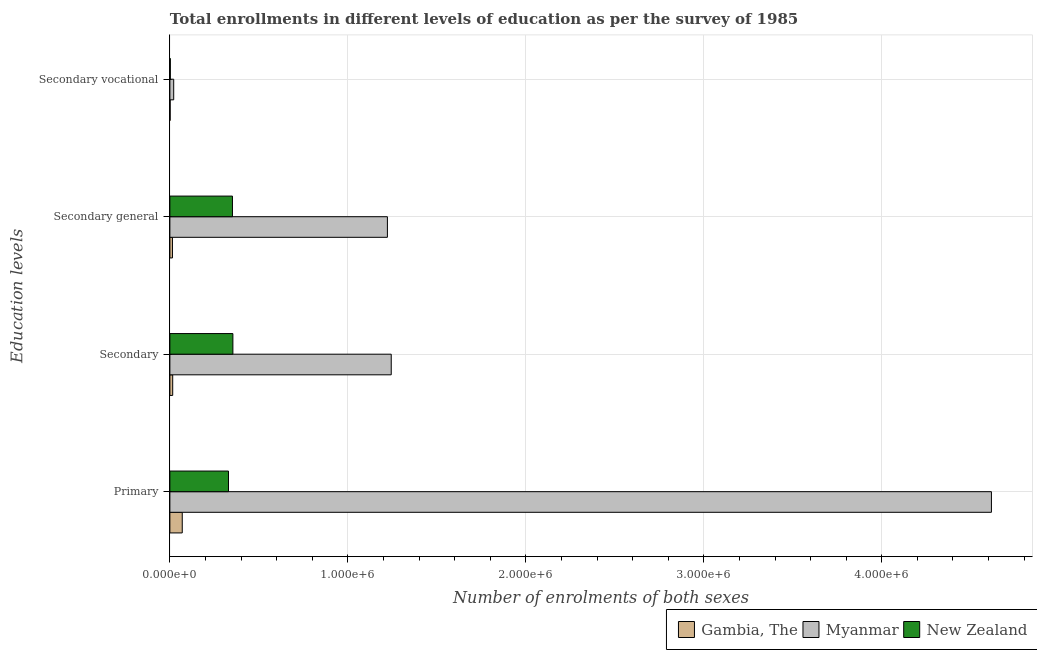How many different coloured bars are there?
Make the answer very short. 3. How many groups of bars are there?
Your answer should be compact. 4. Are the number of bars per tick equal to the number of legend labels?
Provide a succinct answer. Yes. Are the number of bars on each tick of the Y-axis equal?
Provide a succinct answer. Yes. What is the label of the 2nd group of bars from the top?
Your response must be concise. Secondary general. What is the number of enrolments in primary education in New Zealand?
Offer a very short reply. 3.29e+05. Across all countries, what is the maximum number of enrolments in secondary education?
Make the answer very short. 1.24e+06. Across all countries, what is the minimum number of enrolments in primary education?
Give a very brief answer. 6.95e+04. In which country was the number of enrolments in secondary general education maximum?
Keep it short and to the point. Myanmar. In which country was the number of enrolments in secondary vocational education minimum?
Offer a terse response. Gambia, The. What is the total number of enrolments in secondary vocational education in the graph?
Offer a terse response. 2.54e+04. What is the difference between the number of enrolments in secondary general education in New Zealand and that in Gambia, The?
Make the answer very short. 3.37e+05. What is the difference between the number of enrolments in secondary general education in Gambia, The and the number of enrolments in secondary education in New Zealand?
Keep it short and to the point. -3.40e+05. What is the average number of enrolments in secondary general education per country?
Your answer should be very brief. 5.29e+05. What is the difference between the number of enrolments in secondary general education and number of enrolments in secondary education in New Zealand?
Your answer should be very brief. -2462. In how many countries, is the number of enrolments in secondary general education greater than 400000 ?
Give a very brief answer. 1. What is the ratio of the number of enrolments in secondary vocational education in Myanmar to that in New Zealand?
Offer a terse response. 8.73. Is the number of enrolments in secondary general education in Myanmar less than that in New Zealand?
Offer a terse response. No. What is the difference between the highest and the second highest number of enrolments in primary education?
Give a very brief answer. 4.29e+06. What is the difference between the highest and the lowest number of enrolments in secondary general education?
Your answer should be compact. 1.21e+06. In how many countries, is the number of enrolments in primary education greater than the average number of enrolments in primary education taken over all countries?
Provide a short and direct response. 1. Is it the case that in every country, the sum of the number of enrolments in secondary education and number of enrolments in secondary general education is greater than the sum of number of enrolments in primary education and number of enrolments in secondary vocational education?
Make the answer very short. No. What does the 3rd bar from the top in Secondary vocational represents?
Offer a very short reply. Gambia, The. What does the 2nd bar from the bottom in Secondary general represents?
Give a very brief answer. Myanmar. How many bars are there?
Your answer should be very brief. 12. What is the difference between two consecutive major ticks on the X-axis?
Give a very brief answer. 1.00e+06. Does the graph contain any zero values?
Keep it short and to the point. No. Does the graph contain grids?
Give a very brief answer. Yes. Where does the legend appear in the graph?
Provide a short and direct response. Bottom right. How are the legend labels stacked?
Your answer should be compact. Horizontal. What is the title of the graph?
Make the answer very short. Total enrollments in different levels of education as per the survey of 1985. What is the label or title of the X-axis?
Give a very brief answer. Number of enrolments of both sexes. What is the label or title of the Y-axis?
Make the answer very short. Education levels. What is the Number of enrolments of both sexes in Gambia, The in Primary?
Keep it short and to the point. 6.95e+04. What is the Number of enrolments of both sexes of Myanmar in Primary?
Provide a succinct answer. 4.62e+06. What is the Number of enrolments of both sexes in New Zealand in Primary?
Make the answer very short. 3.29e+05. What is the Number of enrolments of both sexes in Gambia, The in Secondary?
Provide a short and direct response. 1.59e+04. What is the Number of enrolments of both sexes of Myanmar in Secondary?
Provide a short and direct response. 1.24e+06. What is the Number of enrolments of both sexes of New Zealand in Secondary?
Offer a terse response. 3.54e+05. What is the Number of enrolments of both sexes in Gambia, The in Secondary general?
Offer a terse response. 1.45e+04. What is the Number of enrolments of both sexes in Myanmar in Secondary general?
Offer a very short reply. 1.22e+06. What is the Number of enrolments of both sexes of New Zealand in Secondary general?
Offer a very short reply. 3.52e+05. What is the Number of enrolments of both sexes in Gambia, The in Secondary vocational?
Your response must be concise. 1460. What is the Number of enrolments of both sexes of Myanmar in Secondary vocational?
Ensure brevity in your answer.  2.15e+04. What is the Number of enrolments of both sexes in New Zealand in Secondary vocational?
Offer a terse response. 2462. Across all Education levels, what is the maximum Number of enrolments of both sexes in Gambia, The?
Ensure brevity in your answer.  6.95e+04. Across all Education levels, what is the maximum Number of enrolments of both sexes in Myanmar?
Make the answer very short. 4.62e+06. Across all Education levels, what is the maximum Number of enrolments of both sexes in New Zealand?
Make the answer very short. 3.54e+05. Across all Education levels, what is the minimum Number of enrolments of both sexes of Gambia, The?
Keep it short and to the point. 1460. Across all Education levels, what is the minimum Number of enrolments of both sexes of Myanmar?
Your answer should be very brief. 2.15e+04. Across all Education levels, what is the minimum Number of enrolments of both sexes of New Zealand?
Make the answer very short. 2462. What is the total Number of enrolments of both sexes of Gambia, The in the graph?
Offer a very short reply. 1.01e+05. What is the total Number of enrolments of both sexes in Myanmar in the graph?
Ensure brevity in your answer.  7.10e+06. What is the total Number of enrolments of both sexes of New Zealand in the graph?
Provide a succinct answer. 1.04e+06. What is the difference between the Number of enrolments of both sexes of Gambia, The in Primary and that in Secondary?
Make the answer very short. 5.36e+04. What is the difference between the Number of enrolments of both sexes of Myanmar in Primary and that in Secondary?
Make the answer very short. 3.37e+06. What is the difference between the Number of enrolments of both sexes in New Zealand in Primary and that in Secondary?
Provide a short and direct response. -2.47e+04. What is the difference between the Number of enrolments of both sexes of Gambia, The in Primary and that in Secondary general?
Your response must be concise. 5.51e+04. What is the difference between the Number of enrolments of both sexes in Myanmar in Primary and that in Secondary general?
Ensure brevity in your answer.  3.39e+06. What is the difference between the Number of enrolments of both sexes of New Zealand in Primary and that in Secondary general?
Your answer should be compact. -2.23e+04. What is the difference between the Number of enrolments of both sexes of Gambia, The in Primary and that in Secondary vocational?
Your response must be concise. 6.81e+04. What is the difference between the Number of enrolments of both sexes in Myanmar in Primary and that in Secondary vocational?
Keep it short and to the point. 4.59e+06. What is the difference between the Number of enrolments of both sexes of New Zealand in Primary and that in Secondary vocational?
Your answer should be very brief. 3.27e+05. What is the difference between the Number of enrolments of both sexes of Gambia, The in Secondary and that in Secondary general?
Your answer should be compact. 1460. What is the difference between the Number of enrolments of both sexes of Myanmar in Secondary and that in Secondary general?
Provide a succinct answer. 2.15e+04. What is the difference between the Number of enrolments of both sexes of New Zealand in Secondary and that in Secondary general?
Offer a terse response. 2462. What is the difference between the Number of enrolments of both sexes in Gambia, The in Secondary and that in Secondary vocational?
Ensure brevity in your answer.  1.45e+04. What is the difference between the Number of enrolments of both sexes of Myanmar in Secondary and that in Secondary vocational?
Provide a succinct answer. 1.22e+06. What is the difference between the Number of enrolments of both sexes of New Zealand in Secondary and that in Secondary vocational?
Your response must be concise. 3.52e+05. What is the difference between the Number of enrolments of both sexes of Gambia, The in Secondary general and that in Secondary vocational?
Provide a short and direct response. 1.30e+04. What is the difference between the Number of enrolments of both sexes of Myanmar in Secondary general and that in Secondary vocational?
Give a very brief answer. 1.20e+06. What is the difference between the Number of enrolments of both sexes in New Zealand in Secondary general and that in Secondary vocational?
Your response must be concise. 3.49e+05. What is the difference between the Number of enrolments of both sexes in Gambia, The in Primary and the Number of enrolments of both sexes in Myanmar in Secondary?
Offer a terse response. -1.17e+06. What is the difference between the Number of enrolments of both sexes of Gambia, The in Primary and the Number of enrolments of both sexes of New Zealand in Secondary?
Offer a very short reply. -2.85e+05. What is the difference between the Number of enrolments of both sexes in Myanmar in Primary and the Number of enrolments of both sexes in New Zealand in Secondary?
Offer a very short reply. 4.26e+06. What is the difference between the Number of enrolments of both sexes in Gambia, The in Primary and the Number of enrolments of both sexes in Myanmar in Secondary general?
Your answer should be compact. -1.15e+06. What is the difference between the Number of enrolments of both sexes in Gambia, The in Primary and the Number of enrolments of both sexes in New Zealand in Secondary general?
Provide a short and direct response. -2.82e+05. What is the difference between the Number of enrolments of both sexes in Myanmar in Primary and the Number of enrolments of both sexes in New Zealand in Secondary general?
Your response must be concise. 4.26e+06. What is the difference between the Number of enrolments of both sexes in Gambia, The in Primary and the Number of enrolments of both sexes in Myanmar in Secondary vocational?
Provide a succinct answer. 4.80e+04. What is the difference between the Number of enrolments of both sexes of Gambia, The in Primary and the Number of enrolments of both sexes of New Zealand in Secondary vocational?
Keep it short and to the point. 6.70e+04. What is the difference between the Number of enrolments of both sexes in Myanmar in Primary and the Number of enrolments of both sexes in New Zealand in Secondary vocational?
Your answer should be compact. 4.61e+06. What is the difference between the Number of enrolments of both sexes of Gambia, The in Secondary and the Number of enrolments of both sexes of Myanmar in Secondary general?
Offer a terse response. -1.21e+06. What is the difference between the Number of enrolments of both sexes of Gambia, The in Secondary and the Number of enrolments of both sexes of New Zealand in Secondary general?
Your response must be concise. -3.36e+05. What is the difference between the Number of enrolments of both sexes of Myanmar in Secondary and the Number of enrolments of both sexes of New Zealand in Secondary general?
Offer a terse response. 8.92e+05. What is the difference between the Number of enrolments of both sexes in Gambia, The in Secondary and the Number of enrolments of both sexes in Myanmar in Secondary vocational?
Make the answer very short. -5587. What is the difference between the Number of enrolments of both sexes in Gambia, The in Secondary and the Number of enrolments of both sexes in New Zealand in Secondary vocational?
Provide a succinct answer. 1.35e+04. What is the difference between the Number of enrolments of both sexes in Myanmar in Secondary and the Number of enrolments of both sexes in New Zealand in Secondary vocational?
Your response must be concise. 1.24e+06. What is the difference between the Number of enrolments of both sexes in Gambia, The in Secondary general and the Number of enrolments of both sexes in Myanmar in Secondary vocational?
Keep it short and to the point. -7047. What is the difference between the Number of enrolments of both sexes of Gambia, The in Secondary general and the Number of enrolments of both sexes of New Zealand in Secondary vocational?
Give a very brief answer. 1.20e+04. What is the difference between the Number of enrolments of both sexes of Myanmar in Secondary general and the Number of enrolments of both sexes of New Zealand in Secondary vocational?
Provide a succinct answer. 1.22e+06. What is the average Number of enrolments of both sexes in Gambia, The per Education levels?
Make the answer very short. 2.53e+04. What is the average Number of enrolments of both sexes in Myanmar per Education levels?
Ensure brevity in your answer.  1.78e+06. What is the average Number of enrolments of both sexes of New Zealand per Education levels?
Your answer should be compact. 2.59e+05. What is the difference between the Number of enrolments of both sexes in Gambia, The and Number of enrolments of both sexes in Myanmar in Primary?
Offer a terse response. -4.55e+06. What is the difference between the Number of enrolments of both sexes of Gambia, The and Number of enrolments of both sexes of New Zealand in Primary?
Provide a short and direct response. -2.60e+05. What is the difference between the Number of enrolments of both sexes of Myanmar and Number of enrolments of both sexes of New Zealand in Primary?
Provide a short and direct response. 4.29e+06. What is the difference between the Number of enrolments of both sexes of Gambia, The and Number of enrolments of both sexes of Myanmar in Secondary?
Provide a short and direct response. -1.23e+06. What is the difference between the Number of enrolments of both sexes in Gambia, The and Number of enrolments of both sexes in New Zealand in Secondary?
Keep it short and to the point. -3.38e+05. What is the difference between the Number of enrolments of both sexes in Myanmar and Number of enrolments of both sexes in New Zealand in Secondary?
Your answer should be very brief. 8.90e+05. What is the difference between the Number of enrolments of both sexes of Gambia, The and Number of enrolments of both sexes of Myanmar in Secondary general?
Ensure brevity in your answer.  -1.21e+06. What is the difference between the Number of enrolments of both sexes of Gambia, The and Number of enrolments of both sexes of New Zealand in Secondary general?
Offer a terse response. -3.37e+05. What is the difference between the Number of enrolments of both sexes in Myanmar and Number of enrolments of both sexes in New Zealand in Secondary general?
Provide a succinct answer. 8.71e+05. What is the difference between the Number of enrolments of both sexes in Gambia, The and Number of enrolments of both sexes in Myanmar in Secondary vocational?
Provide a succinct answer. -2.00e+04. What is the difference between the Number of enrolments of both sexes in Gambia, The and Number of enrolments of both sexes in New Zealand in Secondary vocational?
Give a very brief answer. -1002. What is the difference between the Number of enrolments of both sexes of Myanmar and Number of enrolments of both sexes of New Zealand in Secondary vocational?
Provide a short and direct response. 1.90e+04. What is the ratio of the Number of enrolments of both sexes in Gambia, The in Primary to that in Secondary?
Offer a very short reply. 4.37. What is the ratio of the Number of enrolments of both sexes of Myanmar in Primary to that in Secondary?
Offer a terse response. 3.71. What is the ratio of the Number of enrolments of both sexes in New Zealand in Primary to that in Secondary?
Offer a terse response. 0.93. What is the ratio of the Number of enrolments of both sexes of Gambia, The in Primary to that in Secondary general?
Offer a terse response. 4.81. What is the ratio of the Number of enrolments of both sexes of Myanmar in Primary to that in Secondary general?
Offer a terse response. 3.78. What is the ratio of the Number of enrolments of both sexes in New Zealand in Primary to that in Secondary general?
Your answer should be very brief. 0.94. What is the ratio of the Number of enrolments of both sexes of Gambia, The in Primary to that in Secondary vocational?
Give a very brief answer. 47.61. What is the ratio of the Number of enrolments of both sexes in Myanmar in Primary to that in Secondary vocational?
Provide a short and direct response. 214.69. What is the ratio of the Number of enrolments of both sexes in New Zealand in Primary to that in Secondary vocational?
Keep it short and to the point. 133.77. What is the ratio of the Number of enrolments of both sexes of Gambia, The in Secondary to that in Secondary general?
Offer a terse response. 1.1. What is the ratio of the Number of enrolments of both sexes of Myanmar in Secondary to that in Secondary general?
Give a very brief answer. 1.02. What is the ratio of the Number of enrolments of both sexes in Gambia, The in Secondary to that in Secondary vocational?
Offer a terse response. 10.9. What is the ratio of the Number of enrolments of both sexes of Myanmar in Secondary to that in Secondary vocational?
Your answer should be compact. 57.85. What is the ratio of the Number of enrolments of both sexes in New Zealand in Secondary to that in Secondary vocational?
Offer a very short reply. 143.82. What is the ratio of the Number of enrolments of both sexes of Gambia, The in Secondary general to that in Secondary vocational?
Offer a terse response. 9.9. What is the ratio of the Number of enrolments of both sexes of Myanmar in Secondary general to that in Secondary vocational?
Your answer should be very brief. 56.85. What is the ratio of the Number of enrolments of both sexes in New Zealand in Secondary general to that in Secondary vocational?
Keep it short and to the point. 142.82. What is the difference between the highest and the second highest Number of enrolments of both sexes in Gambia, The?
Your answer should be very brief. 5.36e+04. What is the difference between the highest and the second highest Number of enrolments of both sexes of Myanmar?
Make the answer very short. 3.37e+06. What is the difference between the highest and the second highest Number of enrolments of both sexes in New Zealand?
Offer a terse response. 2462. What is the difference between the highest and the lowest Number of enrolments of both sexes of Gambia, The?
Make the answer very short. 6.81e+04. What is the difference between the highest and the lowest Number of enrolments of both sexes of Myanmar?
Keep it short and to the point. 4.59e+06. What is the difference between the highest and the lowest Number of enrolments of both sexes of New Zealand?
Offer a very short reply. 3.52e+05. 